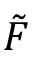<formula> <loc_0><loc_0><loc_500><loc_500>\tilde { F }</formula> 